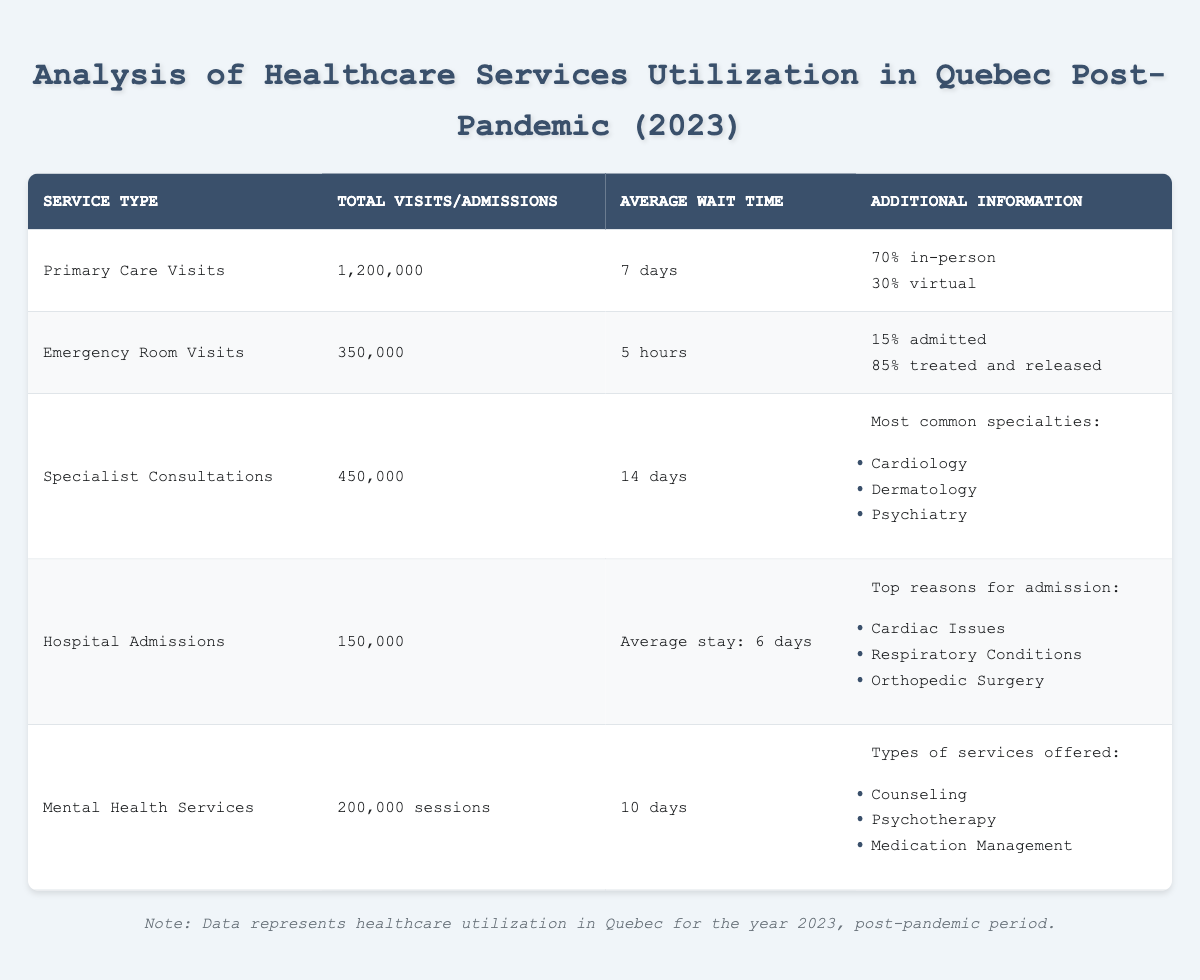What is the total number of visits for Primary Care in 2023? The table lists the total visits for Primary Care as 1,200,000.
Answer: 1,200,000 What percentage of Emergency Room visits were treated and released? According to the table, 85% of Emergency Room visits were treated and released.
Answer: 85% How many total admissions were reported in Hospitals for 2023? The table states the total admissions for Hospitals is 150,000.
Answer: 150,000 What is the average wait time for Specialist Consultations? The table indicates the average wait time for Specialist Consultations is 14 days.
Answer: 14 days Which service type had the highest total visits? By reviewing the total visits, Primary Care had the highest with 1,200,000 visits compared to other services.
Answer: Primary Care What is the average wait time for Mental Health Services compared to Primary Care Visits? The average wait time for Mental Health Services is 10 days and for Primary Care Visits, it is 7 days. 10 days is longer than 7 days, indicating a higher wait time.
Answer: 10 days is longer What percentage of Primary Care visits were virtual? The table shows that 30% of Primary Care visits were virtual.
Answer: 30% What are the top three reasons for Hospital admissions? Based on the data, the top reasons for admissions are Cardiac Issues, Respiratory Conditions, and Orthopedic Surgery.
Answer: Cardiac Issues, Respiratory Conditions, Orthopedic Surgery How many more Emergency Room visits were there compared to Specialist Consultations? The number of Emergency Room visits is 350,000 and Specialist Consultations is 450,000. Therefore, there were 100,000 fewer Emergency Room visits than Specialist Consultations.
Answer: 100,000 fewer Emergency Room visits Is the average length of stay in hospitals longer than the average wait time for Specialist Consultations? The average length of stay in hospitals is 6 days, while the average wait time for Specialist Consultations is 14 days. Since 6 is less than 14, the statement is true.
Answer: Yes, it is shorter 